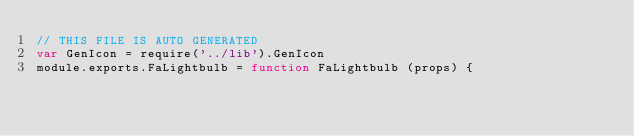<code> <loc_0><loc_0><loc_500><loc_500><_JavaScript_>// THIS FILE IS AUTO GENERATED
var GenIcon = require('../lib').GenIcon
module.exports.FaLightbulb = function FaLightbulb (props) {</code> 